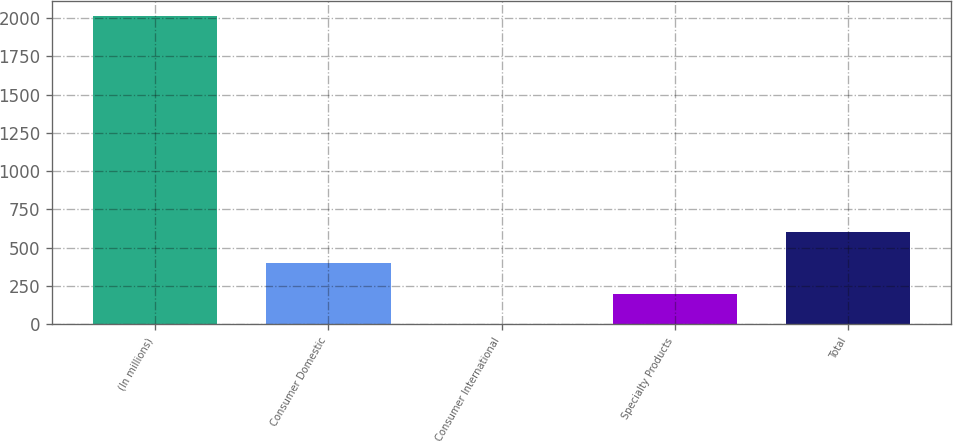Convert chart. <chart><loc_0><loc_0><loc_500><loc_500><bar_chart><fcel>(In millions)<fcel>Consumer Domestic<fcel>Consumer International<fcel>Specialty Products<fcel>Total<nl><fcel>2011<fcel>402.36<fcel>0.2<fcel>201.28<fcel>603.44<nl></chart> 